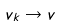<formula> <loc_0><loc_0><loc_500><loc_500>v _ { k } \to v</formula> 